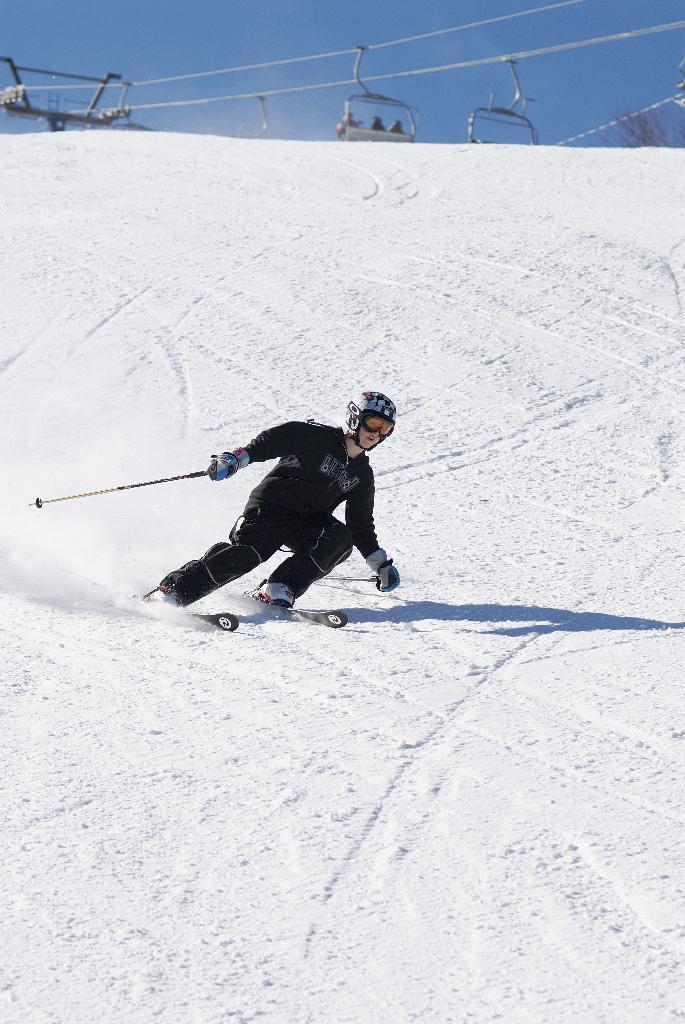How would you summarize this image in a sentence or two? Here we can see a person skiing on ski boards. This is snow and there are cable cars. In the background there is sky. 